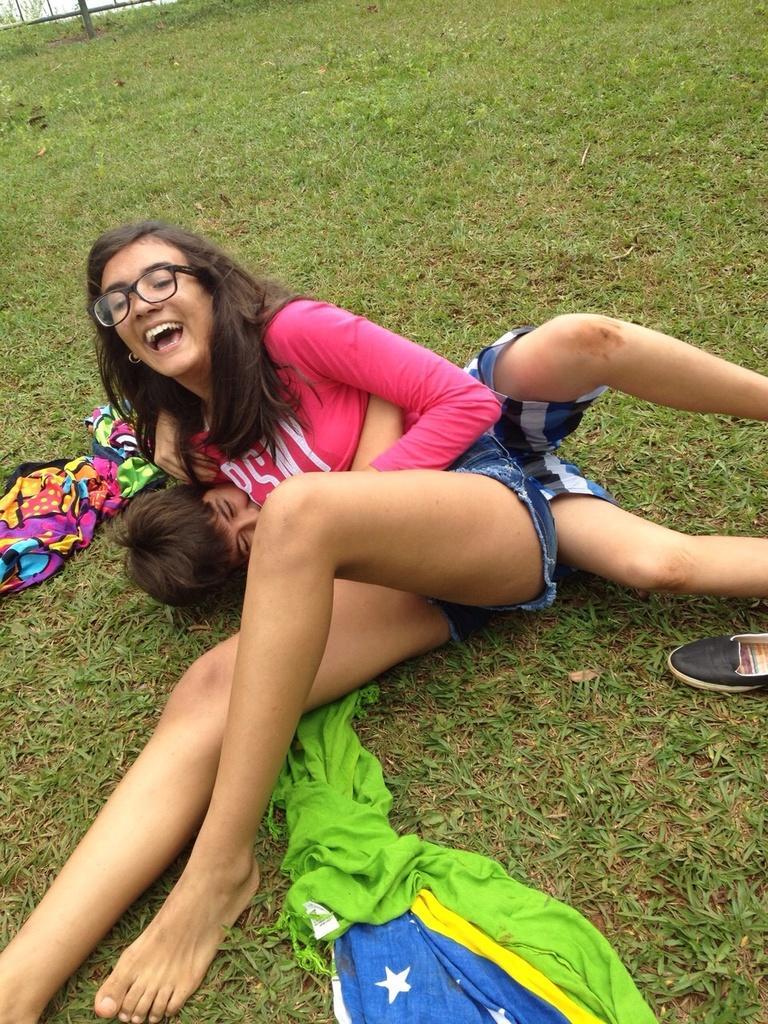Please provide a concise description of this image. In this image a woman wearing spectacles is sitting on the grassland. She is leaning over a person lying on the grass land. There are few clothes and footwear are on the grassland. Left top there is a fence. 